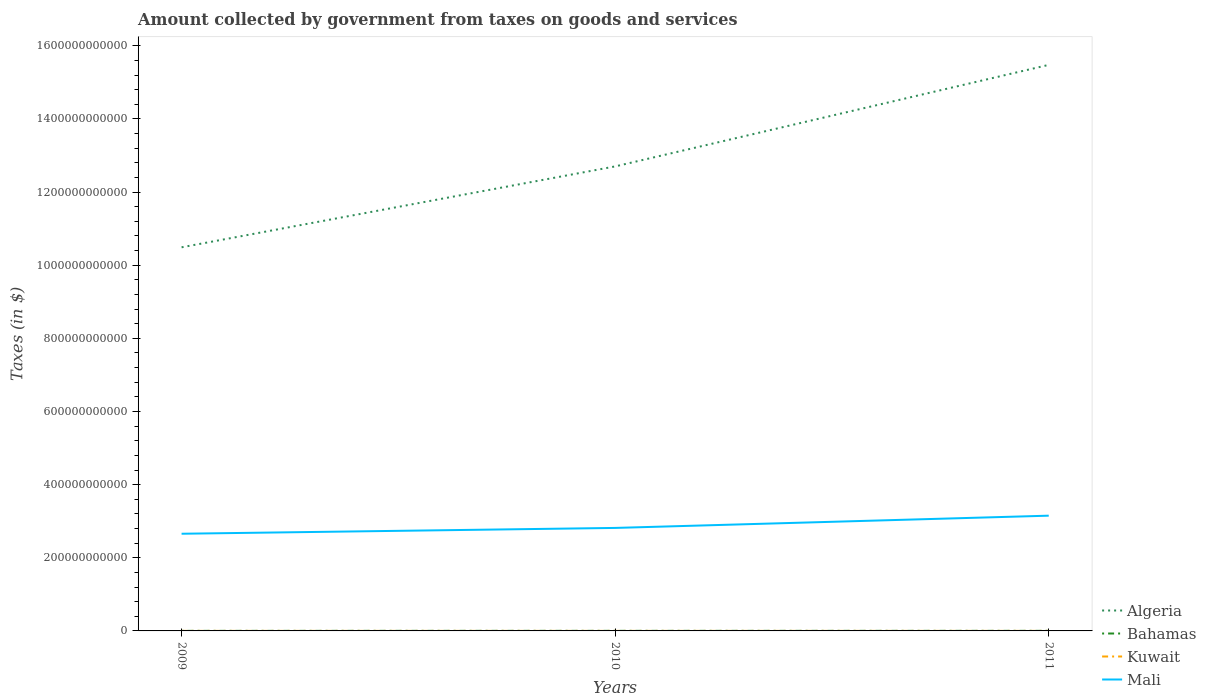Does the line corresponding to Bahamas intersect with the line corresponding to Algeria?
Provide a succinct answer. No. Across all years, what is the maximum amount collected by government from taxes on goods and services in Algeria?
Your answer should be compact. 1.05e+12. In which year was the amount collected by government from taxes on goods and services in Algeria maximum?
Ensure brevity in your answer.  2009. What is the total amount collected by government from taxes on goods and services in Algeria in the graph?
Keep it short and to the point. -2.78e+11. What is the difference between the highest and the second highest amount collected by government from taxes on goods and services in Algeria?
Give a very brief answer. 4.99e+11. What is the difference between the highest and the lowest amount collected by government from taxes on goods and services in Kuwait?
Offer a very short reply. 1. How many lines are there?
Keep it short and to the point. 4. How many years are there in the graph?
Your answer should be compact. 3. What is the difference between two consecutive major ticks on the Y-axis?
Your answer should be compact. 2.00e+11. Are the values on the major ticks of Y-axis written in scientific E-notation?
Give a very brief answer. No. How many legend labels are there?
Keep it short and to the point. 4. What is the title of the graph?
Your answer should be compact. Amount collected by government from taxes on goods and services. What is the label or title of the Y-axis?
Your response must be concise. Taxes (in $). What is the Taxes (in $) in Algeria in 2009?
Provide a succinct answer. 1.05e+12. What is the Taxes (in $) in Bahamas in 2009?
Your response must be concise. 1.80e+08. What is the Taxes (in $) in Kuwait in 2009?
Your answer should be compact. 9.40e+07. What is the Taxes (in $) of Mali in 2009?
Give a very brief answer. 2.66e+11. What is the Taxes (in $) of Algeria in 2010?
Give a very brief answer. 1.27e+12. What is the Taxes (in $) in Bahamas in 2010?
Your answer should be compact. 2.08e+08. What is the Taxes (in $) of Kuwait in 2010?
Ensure brevity in your answer.  8.80e+07. What is the Taxes (in $) in Mali in 2010?
Make the answer very short. 2.82e+11. What is the Taxes (in $) of Algeria in 2011?
Offer a terse response. 1.55e+12. What is the Taxes (in $) in Bahamas in 2011?
Provide a succinct answer. 2.20e+08. What is the Taxes (in $) of Kuwait in 2011?
Your response must be concise. 8.60e+07. What is the Taxes (in $) in Mali in 2011?
Ensure brevity in your answer.  3.15e+11. Across all years, what is the maximum Taxes (in $) of Algeria?
Offer a very short reply. 1.55e+12. Across all years, what is the maximum Taxes (in $) in Bahamas?
Offer a very short reply. 2.20e+08. Across all years, what is the maximum Taxes (in $) of Kuwait?
Offer a very short reply. 9.40e+07. Across all years, what is the maximum Taxes (in $) of Mali?
Provide a succinct answer. 3.15e+11. Across all years, what is the minimum Taxes (in $) of Algeria?
Your answer should be very brief. 1.05e+12. Across all years, what is the minimum Taxes (in $) of Bahamas?
Your response must be concise. 1.80e+08. Across all years, what is the minimum Taxes (in $) in Kuwait?
Offer a terse response. 8.60e+07. Across all years, what is the minimum Taxes (in $) in Mali?
Provide a short and direct response. 2.66e+11. What is the total Taxes (in $) of Algeria in the graph?
Give a very brief answer. 3.87e+12. What is the total Taxes (in $) of Bahamas in the graph?
Give a very brief answer. 6.09e+08. What is the total Taxes (in $) of Kuwait in the graph?
Make the answer very short. 2.68e+08. What is the total Taxes (in $) of Mali in the graph?
Your response must be concise. 8.62e+11. What is the difference between the Taxes (in $) in Algeria in 2009 and that in 2010?
Provide a short and direct response. -2.21e+11. What is the difference between the Taxes (in $) in Bahamas in 2009 and that in 2010?
Your answer should be very brief. -2.80e+07. What is the difference between the Taxes (in $) in Mali in 2009 and that in 2010?
Your answer should be very brief. -1.59e+1. What is the difference between the Taxes (in $) of Algeria in 2009 and that in 2011?
Ensure brevity in your answer.  -4.99e+11. What is the difference between the Taxes (in $) in Bahamas in 2009 and that in 2011?
Offer a very short reply. -3.93e+07. What is the difference between the Taxes (in $) of Kuwait in 2009 and that in 2011?
Keep it short and to the point. 8.00e+06. What is the difference between the Taxes (in $) of Mali in 2009 and that in 2011?
Provide a short and direct response. -4.94e+1. What is the difference between the Taxes (in $) in Algeria in 2010 and that in 2011?
Offer a very short reply. -2.78e+11. What is the difference between the Taxes (in $) in Bahamas in 2010 and that in 2011?
Offer a very short reply. -1.13e+07. What is the difference between the Taxes (in $) in Mali in 2010 and that in 2011?
Provide a succinct answer. -3.35e+1. What is the difference between the Taxes (in $) in Algeria in 2009 and the Taxes (in $) in Bahamas in 2010?
Provide a short and direct response. 1.05e+12. What is the difference between the Taxes (in $) of Algeria in 2009 and the Taxes (in $) of Kuwait in 2010?
Offer a very short reply. 1.05e+12. What is the difference between the Taxes (in $) of Algeria in 2009 and the Taxes (in $) of Mali in 2010?
Your answer should be very brief. 7.67e+11. What is the difference between the Taxes (in $) in Bahamas in 2009 and the Taxes (in $) in Kuwait in 2010?
Provide a succinct answer. 9.25e+07. What is the difference between the Taxes (in $) of Bahamas in 2009 and the Taxes (in $) of Mali in 2010?
Your answer should be compact. -2.81e+11. What is the difference between the Taxes (in $) of Kuwait in 2009 and the Taxes (in $) of Mali in 2010?
Ensure brevity in your answer.  -2.82e+11. What is the difference between the Taxes (in $) of Algeria in 2009 and the Taxes (in $) of Bahamas in 2011?
Ensure brevity in your answer.  1.05e+12. What is the difference between the Taxes (in $) of Algeria in 2009 and the Taxes (in $) of Kuwait in 2011?
Offer a terse response. 1.05e+12. What is the difference between the Taxes (in $) of Algeria in 2009 and the Taxes (in $) of Mali in 2011?
Provide a succinct answer. 7.34e+11. What is the difference between the Taxes (in $) of Bahamas in 2009 and the Taxes (in $) of Kuwait in 2011?
Make the answer very short. 9.45e+07. What is the difference between the Taxes (in $) in Bahamas in 2009 and the Taxes (in $) in Mali in 2011?
Provide a short and direct response. -3.15e+11. What is the difference between the Taxes (in $) of Kuwait in 2009 and the Taxes (in $) of Mali in 2011?
Provide a short and direct response. -3.15e+11. What is the difference between the Taxes (in $) of Algeria in 2010 and the Taxes (in $) of Bahamas in 2011?
Provide a succinct answer. 1.27e+12. What is the difference between the Taxes (in $) of Algeria in 2010 and the Taxes (in $) of Kuwait in 2011?
Provide a succinct answer. 1.27e+12. What is the difference between the Taxes (in $) in Algeria in 2010 and the Taxes (in $) in Mali in 2011?
Your response must be concise. 9.55e+11. What is the difference between the Taxes (in $) in Bahamas in 2010 and the Taxes (in $) in Kuwait in 2011?
Offer a terse response. 1.22e+08. What is the difference between the Taxes (in $) in Bahamas in 2010 and the Taxes (in $) in Mali in 2011?
Offer a terse response. -3.15e+11. What is the difference between the Taxes (in $) in Kuwait in 2010 and the Taxes (in $) in Mali in 2011?
Your answer should be compact. -3.15e+11. What is the average Taxes (in $) in Algeria per year?
Keep it short and to the point. 1.29e+12. What is the average Taxes (in $) in Bahamas per year?
Your answer should be very brief. 2.03e+08. What is the average Taxes (in $) of Kuwait per year?
Keep it short and to the point. 8.93e+07. What is the average Taxes (in $) of Mali per year?
Provide a succinct answer. 2.87e+11. In the year 2009, what is the difference between the Taxes (in $) in Algeria and Taxes (in $) in Bahamas?
Offer a terse response. 1.05e+12. In the year 2009, what is the difference between the Taxes (in $) in Algeria and Taxes (in $) in Kuwait?
Your answer should be very brief. 1.05e+12. In the year 2009, what is the difference between the Taxes (in $) of Algeria and Taxes (in $) of Mali?
Provide a short and direct response. 7.83e+11. In the year 2009, what is the difference between the Taxes (in $) of Bahamas and Taxes (in $) of Kuwait?
Make the answer very short. 8.65e+07. In the year 2009, what is the difference between the Taxes (in $) of Bahamas and Taxes (in $) of Mali?
Make the answer very short. -2.66e+11. In the year 2009, what is the difference between the Taxes (in $) in Kuwait and Taxes (in $) in Mali?
Ensure brevity in your answer.  -2.66e+11. In the year 2010, what is the difference between the Taxes (in $) of Algeria and Taxes (in $) of Bahamas?
Keep it short and to the point. 1.27e+12. In the year 2010, what is the difference between the Taxes (in $) in Algeria and Taxes (in $) in Kuwait?
Your answer should be very brief. 1.27e+12. In the year 2010, what is the difference between the Taxes (in $) of Algeria and Taxes (in $) of Mali?
Keep it short and to the point. 9.88e+11. In the year 2010, what is the difference between the Taxes (in $) in Bahamas and Taxes (in $) in Kuwait?
Offer a terse response. 1.20e+08. In the year 2010, what is the difference between the Taxes (in $) in Bahamas and Taxes (in $) in Mali?
Give a very brief answer. -2.81e+11. In the year 2010, what is the difference between the Taxes (in $) of Kuwait and Taxes (in $) of Mali?
Keep it short and to the point. -2.82e+11. In the year 2011, what is the difference between the Taxes (in $) in Algeria and Taxes (in $) in Bahamas?
Offer a terse response. 1.55e+12. In the year 2011, what is the difference between the Taxes (in $) of Algeria and Taxes (in $) of Kuwait?
Keep it short and to the point. 1.55e+12. In the year 2011, what is the difference between the Taxes (in $) of Algeria and Taxes (in $) of Mali?
Make the answer very short. 1.23e+12. In the year 2011, what is the difference between the Taxes (in $) of Bahamas and Taxes (in $) of Kuwait?
Keep it short and to the point. 1.34e+08. In the year 2011, what is the difference between the Taxes (in $) in Bahamas and Taxes (in $) in Mali?
Provide a succinct answer. -3.15e+11. In the year 2011, what is the difference between the Taxes (in $) in Kuwait and Taxes (in $) in Mali?
Your response must be concise. -3.15e+11. What is the ratio of the Taxes (in $) of Algeria in 2009 to that in 2010?
Offer a terse response. 0.83. What is the ratio of the Taxes (in $) in Bahamas in 2009 to that in 2010?
Provide a succinct answer. 0.87. What is the ratio of the Taxes (in $) in Kuwait in 2009 to that in 2010?
Make the answer very short. 1.07. What is the ratio of the Taxes (in $) of Mali in 2009 to that in 2010?
Provide a succinct answer. 0.94. What is the ratio of the Taxes (in $) of Algeria in 2009 to that in 2011?
Offer a very short reply. 0.68. What is the ratio of the Taxes (in $) in Bahamas in 2009 to that in 2011?
Provide a succinct answer. 0.82. What is the ratio of the Taxes (in $) of Kuwait in 2009 to that in 2011?
Offer a very short reply. 1.09. What is the ratio of the Taxes (in $) in Mali in 2009 to that in 2011?
Your answer should be compact. 0.84. What is the ratio of the Taxes (in $) of Algeria in 2010 to that in 2011?
Offer a terse response. 0.82. What is the ratio of the Taxes (in $) in Bahamas in 2010 to that in 2011?
Your response must be concise. 0.95. What is the ratio of the Taxes (in $) in Kuwait in 2010 to that in 2011?
Offer a terse response. 1.02. What is the ratio of the Taxes (in $) in Mali in 2010 to that in 2011?
Your answer should be compact. 0.89. What is the difference between the highest and the second highest Taxes (in $) in Algeria?
Make the answer very short. 2.78e+11. What is the difference between the highest and the second highest Taxes (in $) of Bahamas?
Offer a terse response. 1.13e+07. What is the difference between the highest and the second highest Taxes (in $) of Mali?
Provide a succinct answer. 3.35e+1. What is the difference between the highest and the lowest Taxes (in $) of Algeria?
Your answer should be compact. 4.99e+11. What is the difference between the highest and the lowest Taxes (in $) in Bahamas?
Ensure brevity in your answer.  3.93e+07. What is the difference between the highest and the lowest Taxes (in $) of Mali?
Offer a terse response. 4.94e+1. 